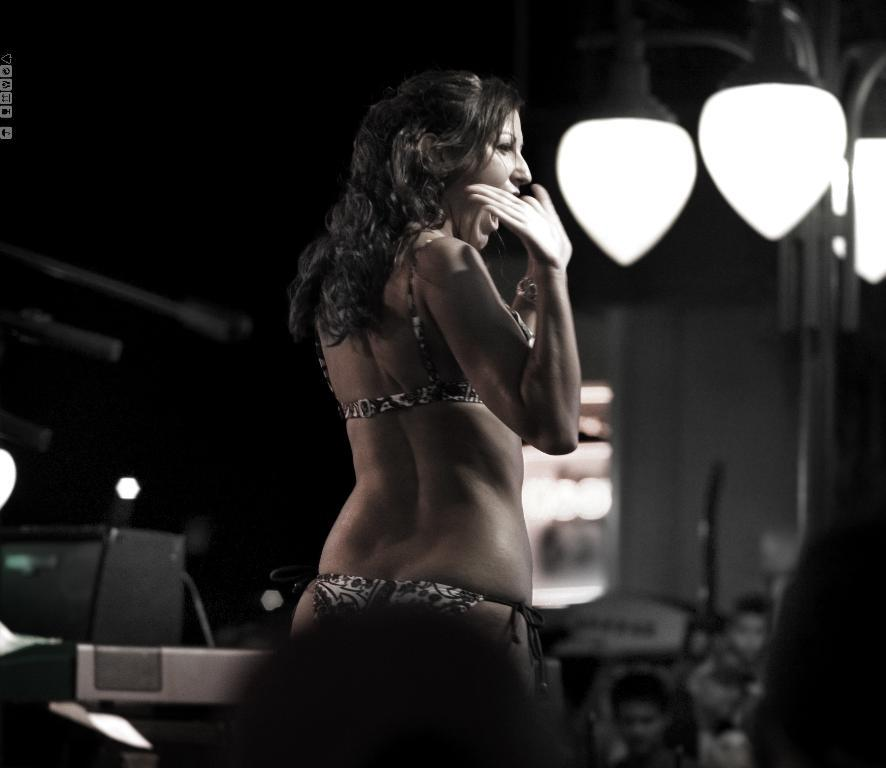What is the main subject of the image? There is a lady standing in the center of the image. Can you describe the background of the image? There are lights visible in the background of the image. What channel is the lady watching on the television in the image? There is no television present in the image, so it is not possible to determine what channel the lady might be watching. 